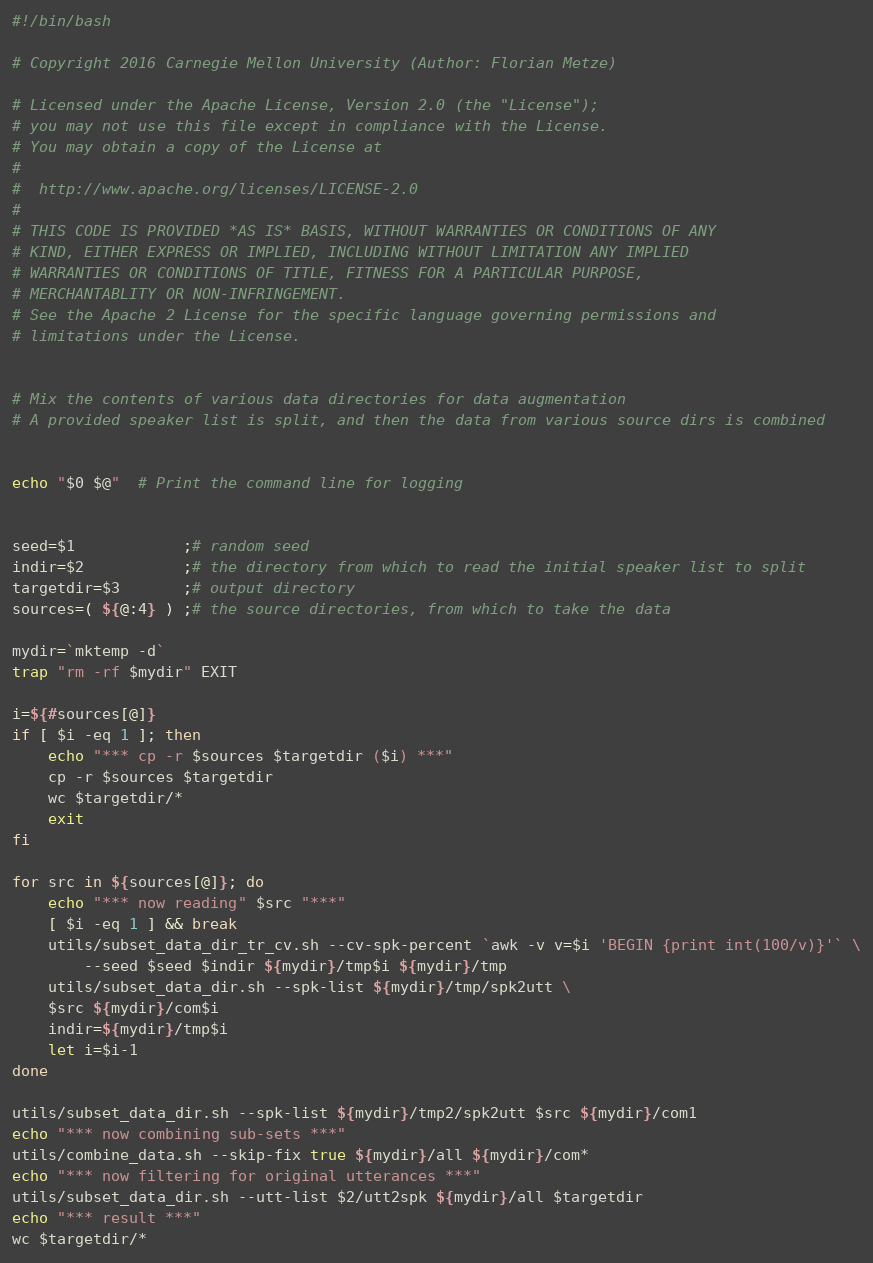<code> <loc_0><loc_0><loc_500><loc_500><_Bash_>#!/bin/bash

# Copyright 2016 Carnegie Mellon University (Author: Florian Metze)

# Licensed under the Apache License, Version 2.0 (the "License");
# you may not use this file except in compliance with the License.
# You may obtain a copy of the License at
#
#  http://www.apache.org/licenses/LICENSE-2.0
#
# THIS CODE IS PROVIDED *AS IS* BASIS, WITHOUT WARRANTIES OR CONDITIONS OF ANY
# KIND, EITHER EXPRESS OR IMPLIED, INCLUDING WITHOUT LIMITATION ANY IMPLIED
# WARRANTIES OR CONDITIONS OF TITLE, FITNESS FOR A PARTICULAR PURPOSE,
# MERCHANTABLITY OR NON-INFRINGEMENT.
# See the Apache 2 License for the specific language governing permissions and
# limitations under the License.


# Mix the contents of various data directories for data augmentation
# A provided speaker list is split, and then the data from various source dirs is combined


echo "$0 $@"  # Print the command line for logging


seed=$1            ;# random seed
indir=$2           ;# the directory from which to read the initial speaker list to split
targetdir=$3       ;# output directory
sources=( ${@:4} ) ;# the source directories, from which to take the data

mydir=`mktemp -d`
trap "rm -rf $mydir" EXIT

i=${#sources[@]}
if [ $i -eq 1 ]; then
    echo "*** cp -r $sources $targetdir ($i) ***"
    cp -r $sources $targetdir
    wc $targetdir/*
    exit
fi

for src in ${sources[@]}; do
    echo "*** now reading" $src "***"
    [ $i -eq 1 ] && break
    utils/subset_data_dir_tr_cv.sh --cv-spk-percent `awk -v v=$i 'BEGIN {print int(100/v)}'` \
        --seed $seed $indir ${mydir}/tmp$i ${mydir}/tmp
    utils/subset_data_dir.sh --spk-list ${mydir}/tmp/spk2utt \
	$src ${mydir}/com$i
    indir=${mydir}/tmp$i
    let i=$i-1
done

utils/subset_data_dir.sh --spk-list ${mydir}/tmp2/spk2utt $src ${mydir}/com1
echo "*** now combining sub-sets ***"
utils/combine_data.sh --skip-fix true ${mydir}/all ${mydir}/com*
echo "*** now filtering for original utterances ***"
utils/subset_data_dir.sh --utt-list $2/utt2spk ${mydir}/all $targetdir
echo "*** result ***"
wc $targetdir/*
</code> 